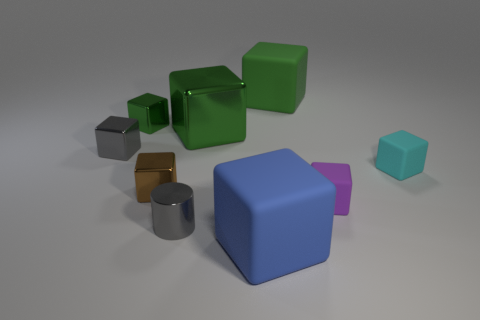Do the green thing that is left of the large green shiny object and the big object in front of the tiny gray metallic block have the same material?
Your answer should be compact. No. What size is the matte thing to the left of the big rubber cube that is behind the gray object that is in front of the small cyan block?
Give a very brief answer. Large. There is a blue object that is the same size as the green rubber block; what is it made of?
Ensure brevity in your answer.  Rubber. Is there a blue rubber cylinder that has the same size as the purple object?
Ensure brevity in your answer.  No. Does the small brown metal thing have the same shape as the purple thing?
Ensure brevity in your answer.  Yes. There is a large rubber object that is right of the big rubber object in front of the tiny cyan block; are there any purple rubber blocks behind it?
Your answer should be compact. No. What number of other things are there of the same color as the small cylinder?
Your response must be concise. 1. There is a gray object in front of the cyan rubber thing; does it have the same size as the thing that is to the right of the purple rubber block?
Ensure brevity in your answer.  Yes. Are there the same number of metal cylinders that are left of the tiny cyan cube and big blue rubber cubes behind the large blue block?
Keep it short and to the point. No. Is there anything else that is made of the same material as the small cylinder?
Give a very brief answer. Yes. 